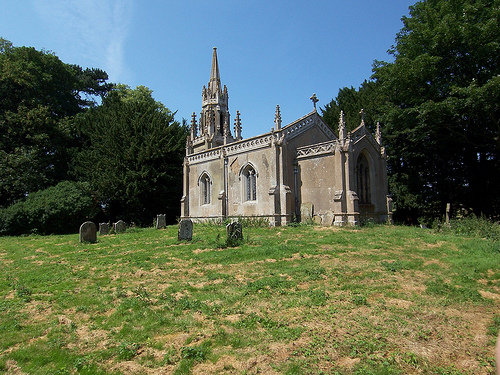<image>
Is there a grave stone under the tree? Yes. The grave stone is positioned underneath the tree, with the tree above it in the vertical space. Where is the church in relation to the grass? Is it in front of the grass? No. The church is not in front of the grass. The spatial positioning shows a different relationship between these objects. 